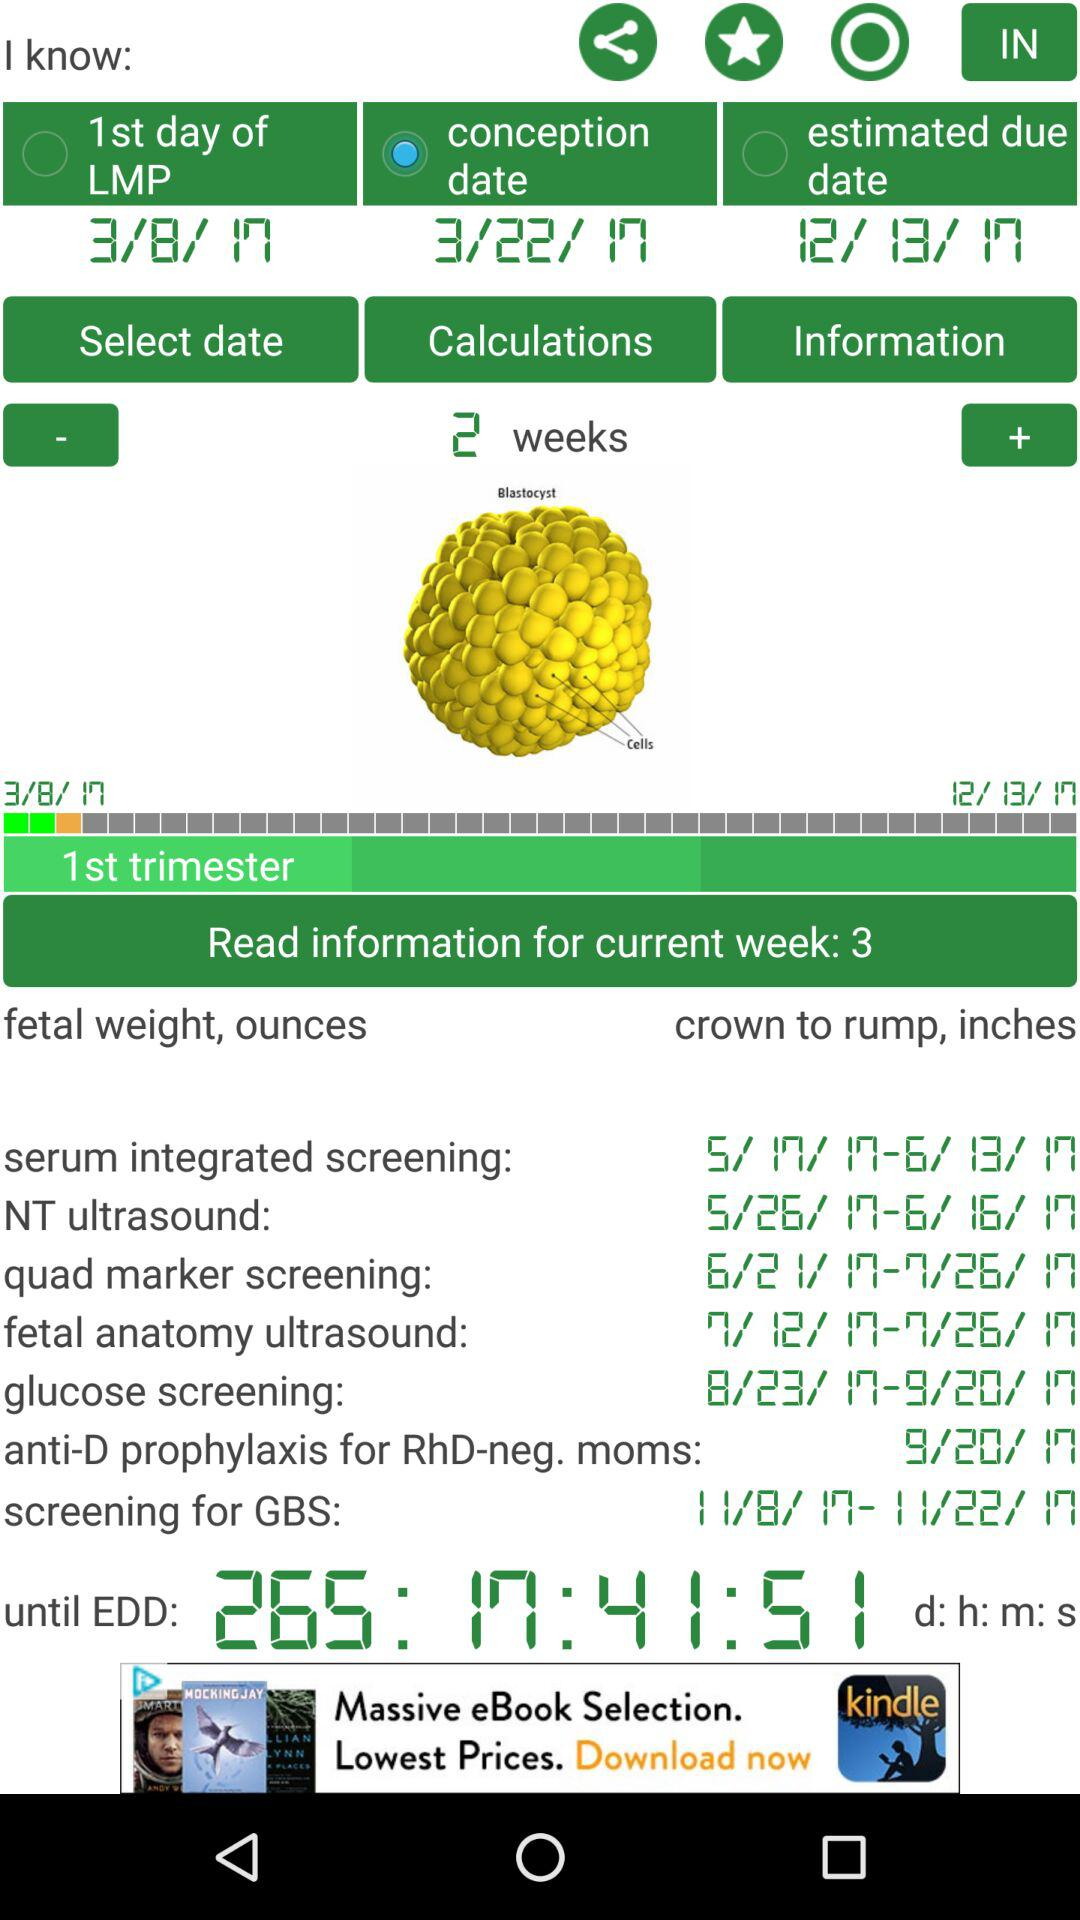How much time is left until EDD? The time left until EDD is 265 days 17 hours 41 minutes 51 seconds. 